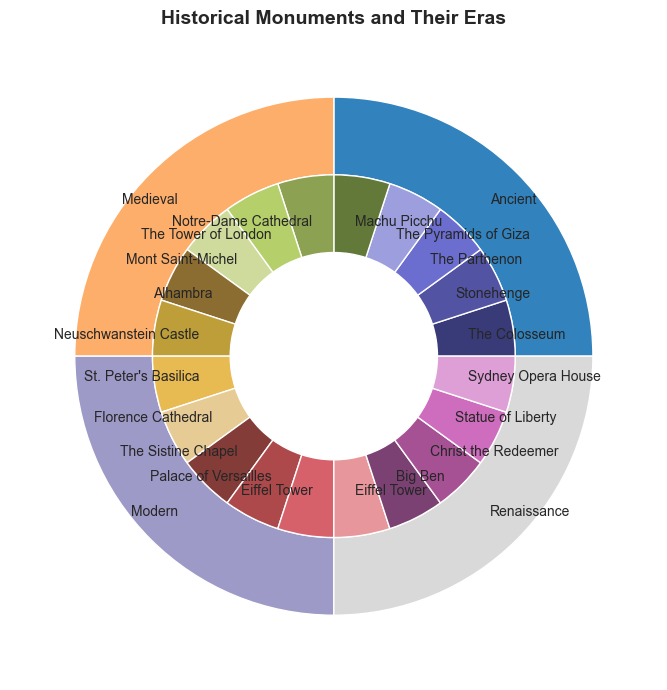What percentage of the total monuments are from the Ancient era? The pie chart shows that each era is represented separately. Count the slices in each era; there are 5 monuments in Ancient and a total of 20 monuments. Calculate (5/20) * 100 to find the percentage.
Answer: 25% Which era has more monuments: Renaissance or Medieval? Compare the sizes and count the slices for each era's pie segment. Renaissance has 5 monuments, while Medieval also has 5 monuments; they are equal in number.
Answer: Equal How many more monuments are there in the Modern era compared to the Ancient era? Count the slices for each era. Both Modern and Ancient have 5 monuments each, so the difference is 0.
Answer: 0 Which era is represented by the most vibrant colors in the inner layer? Observe the colors used for the outer pie segments representing eras. Identify the colors that stand out the most vividly; description might be subjective, but suppose Modern era's colors appear more vibrant.
Answer: Modern List all the monuments found in the Renaissance era. Check the inner pie chart layer for the Renaissance segment, then look at the corresponding outer pie segments for label names. The monuments are: St. Peter's Basilica, Florence Cathedral, The Sistine Chapel, Palace of Versailles, Eiffel Tower.
Answer: St. Peter's Basilica, Florence Cathedral, The Sistine Chapel, Palace of Versailles, Eiffel Tower How does the count of monuments in the Ancient era compare to the count in the Modern era? Both counts are derived by looking at the chart and counting the slices within the respective outer pie segments. Ancient and Modern both have 5 monuments each; thus, they are equal.
Answer: Equal What fraction of the total monuments does the Medieval era represent? The total number of monuments is 20. Count the slices in the Medieval era, which is 5. The fraction is 5/20.
Answer: 1/4 Identify the monument that appears in both the Renaissance and Modern eras. Cross-reference the list of monuments across the Renaissance and Modern eras and identify any overlapping name; the only repetition is the Eiffel Tower.
Answer: Eiffel Tower Which era has the smallest representation in the pie chart? Visually compare the sizes of the pie segments and count the slices. Since every era has an equal number of monuments (5 each), none of the eras is the smallest.
Answer: None How many total monuments are there across all eras? Sum up the count of monuments across all the eras by adding up the slices in all pie segments. Ancient (5) + Medieval (5) + Renaissance (5) + Modern (5) = 20.
Answer: 20 